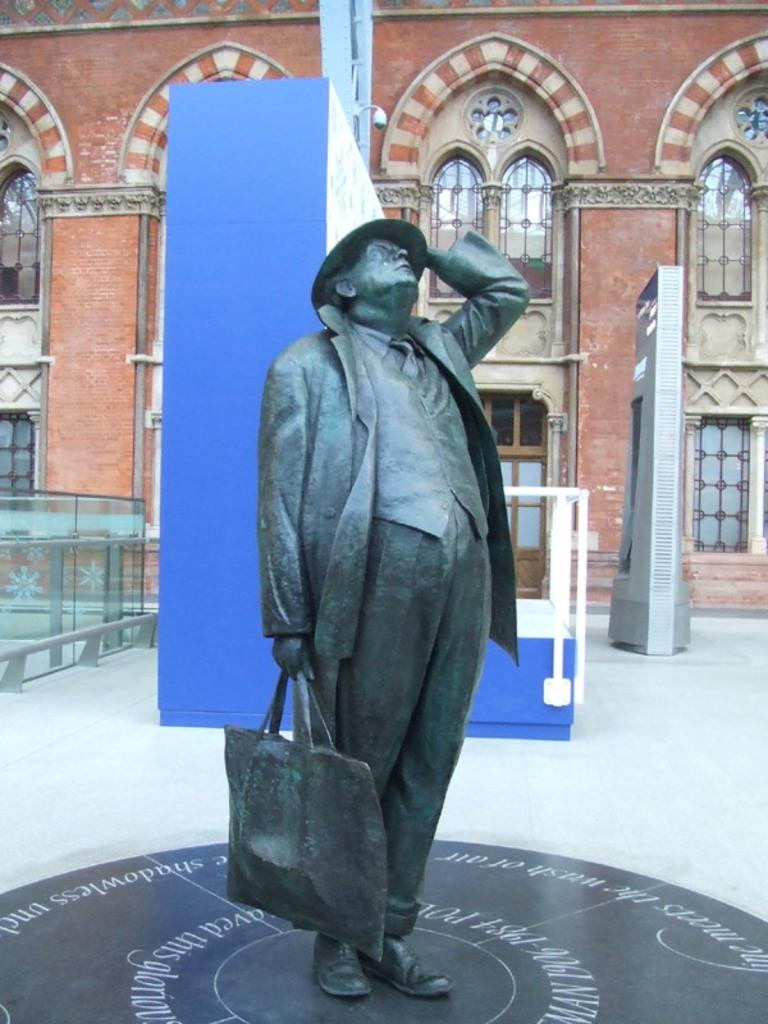What is the main subject in the foreground of the image? There is a statue in front of a building in the image. What can be seen in the background of the image? Metal rods and windows are visible in the background of the image. What type of fuel is being used by the apparatus in the image? There is no apparatus or fuel present in the image. Can you read any writing on the statue in the image? There is no writing visible on the statue in the image. 